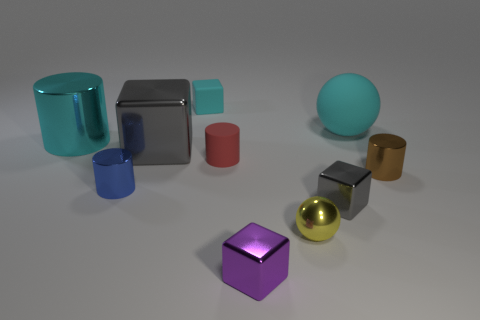Subtract all small blue metal cylinders. How many cylinders are left? 3 Subtract all purple cubes. How many cubes are left? 3 Subtract all cylinders. How many objects are left? 6 Subtract 2 balls. How many balls are left? 0 Add 2 tiny purple metal blocks. How many tiny purple metal blocks are left? 3 Add 3 small gray rubber balls. How many small gray rubber balls exist? 3 Subtract 1 blue cylinders. How many objects are left? 9 Subtract all brown cylinders. Subtract all blue cubes. How many cylinders are left? 3 Subtract all green cylinders. How many yellow cubes are left? 0 Subtract all purple metallic cubes. Subtract all blue shiny things. How many objects are left? 8 